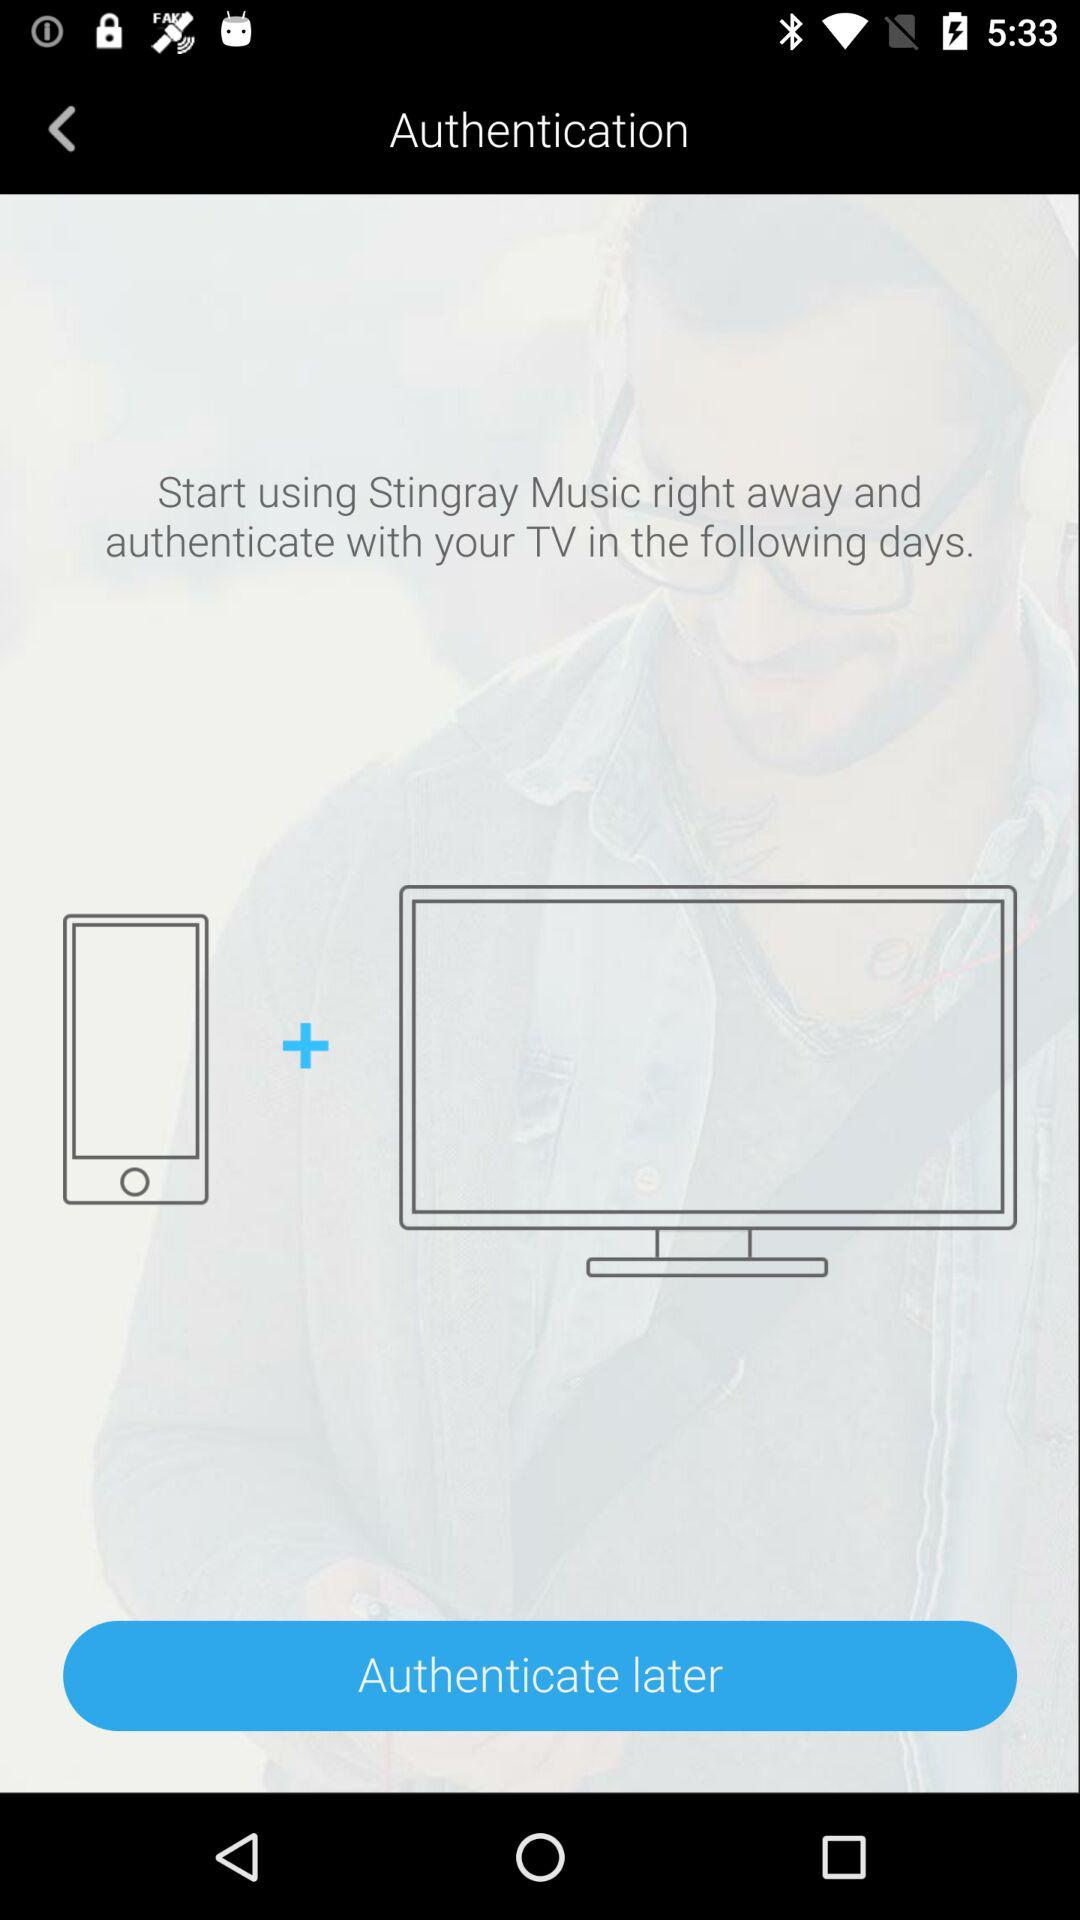What is the application name? The application name is "Stingray Music". 